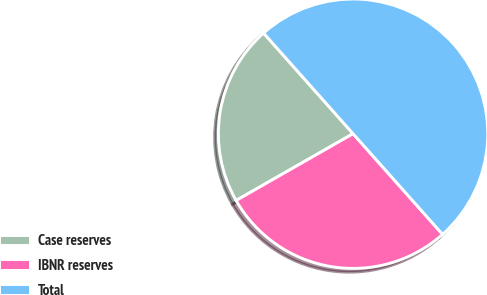Convert chart to OTSL. <chart><loc_0><loc_0><loc_500><loc_500><pie_chart><fcel>Case reserves<fcel>IBNR reserves<fcel>Total<nl><fcel>21.69%<fcel>28.31%<fcel>50.0%<nl></chart> 